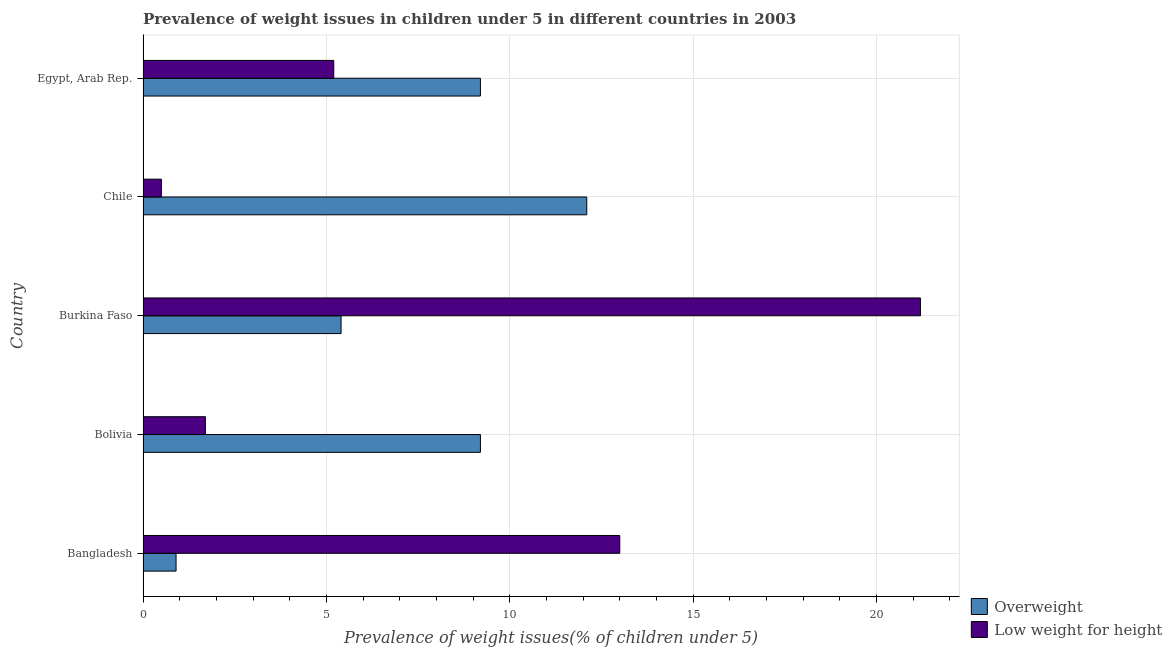How many different coloured bars are there?
Your answer should be very brief. 2. How many groups of bars are there?
Keep it short and to the point. 5. Are the number of bars per tick equal to the number of legend labels?
Ensure brevity in your answer.  Yes. How many bars are there on the 4th tick from the top?
Offer a terse response. 2. How many bars are there on the 1st tick from the bottom?
Your answer should be very brief. 2. In how many cases, is the number of bars for a given country not equal to the number of legend labels?
Give a very brief answer. 0. What is the percentage of underweight children in Bolivia?
Offer a very short reply. 1.7. Across all countries, what is the maximum percentage of overweight children?
Provide a succinct answer. 12.1. What is the total percentage of underweight children in the graph?
Offer a very short reply. 41.6. What is the difference between the percentage of underweight children in Egypt, Arab Rep. and the percentage of overweight children in Bolivia?
Your answer should be very brief. -4. What is the average percentage of underweight children per country?
Offer a very short reply. 8.32. What is the difference between the percentage of underweight children and percentage of overweight children in Bangladesh?
Give a very brief answer. 12.1. In how many countries, is the percentage of underweight children greater than 2 %?
Offer a terse response. 3. What is the ratio of the percentage of overweight children in Bolivia to that in Chile?
Provide a succinct answer. 0.76. Is the difference between the percentage of overweight children in Burkina Faso and Egypt, Arab Rep. greater than the difference between the percentage of underweight children in Burkina Faso and Egypt, Arab Rep.?
Provide a short and direct response. No. What is the difference between the highest and the second highest percentage of underweight children?
Ensure brevity in your answer.  8.2. What is the difference between the highest and the lowest percentage of underweight children?
Your answer should be compact. 20.7. In how many countries, is the percentage of overweight children greater than the average percentage of overweight children taken over all countries?
Provide a short and direct response. 3. Is the sum of the percentage of underweight children in Bangladesh and Chile greater than the maximum percentage of overweight children across all countries?
Give a very brief answer. Yes. What does the 2nd bar from the top in Chile represents?
Offer a very short reply. Overweight. What does the 2nd bar from the bottom in Burkina Faso represents?
Your response must be concise. Low weight for height. How many bars are there?
Provide a short and direct response. 10. Are all the bars in the graph horizontal?
Make the answer very short. Yes. How many countries are there in the graph?
Your answer should be very brief. 5. Does the graph contain grids?
Offer a terse response. Yes. Where does the legend appear in the graph?
Ensure brevity in your answer.  Bottom right. What is the title of the graph?
Your answer should be very brief. Prevalence of weight issues in children under 5 in different countries in 2003. What is the label or title of the X-axis?
Your answer should be compact. Prevalence of weight issues(% of children under 5). What is the Prevalence of weight issues(% of children under 5) of Overweight in Bangladesh?
Your response must be concise. 0.9. What is the Prevalence of weight issues(% of children under 5) in Low weight for height in Bangladesh?
Offer a very short reply. 13. What is the Prevalence of weight issues(% of children under 5) in Overweight in Bolivia?
Provide a succinct answer. 9.2. What is the Prevalence of weight issues(% of children under 5) of Low weight for height in Bolivia?
Your answer should be very brief. 1.7. What is the Prevalence of weight issues(% of children under 5) of Overweight in Burkina Faso?
Ensure brevity in your answer.  5.4. What is the Prevalence of weight issues(% of children under 5) of Low weight for height in Burkina Faso?
Your answer should be very brief. 21.2. What is the Prevalence of weight issues(% of children under 5) in Overweight in Chile?
Your answer should be compact. 12.1. What is the Prevalence of weight issues(% of children under 5) of Low weight for height in Chile?
Your answer should be compact. 0.5. What is the Prevalence of weight issues(% of children under 5) in Overweight in Egypt, Arab Rep.?
Offer a very short reply. 9.2. What is the Prevalence of weight issues(% of children under 5) in Low weight for height in Egypt, Arab Rep.?
Your response must be concise. 5.2. Across all countries, what is the maximum Prevalence of weight issues(% of children under 5) of Overweight?
Provide a short and direct response. 12.1. Across all countries, what is the maximum Prevalence of weight issues(% of children under 5) in Low weight for height?
Keep it short and to the point. 21.2. Across all countries, what is the minimum Prevalence of weight issues(% of children under 5) of Overweight?
Give a very brief answer. 0.9. What is the total Prevalence of weight issues(% of children under 5) of Overweight in the graph?
Keep it short and to the point. 36.8. What is the total Prevalence of weight issues(% of children under 5) in Low weight for height in the graph?
Give a very brief answer. 41.6. What is the difference between the Prevalence of weight issues(% of children under 5) of Overweight in Bangladesh and that in Bolivia?
Ensure brevity in your answer.  -8.3. What is the difference between the Prevalence of weight issues(% of children under 5) in Low weight for height in Bangladesh and that in Chile?
Make the answer very short. 12.5. What is the difference between the Prevalence of weight issues(% of children under 5) in Low weight for height in Bolivia and that in Burkina Faso?
Your answer should be very brief. -19.5. What is the difference between the Prevalence of weight issues(% of children under 5) of Low weight for height in Bolivia and that in Egypt, Arab Rep.?
Your answer should be very brief. -3.5. What is the difference between the Prevalence of weight issues(% of children under 5) in Overweight in Burkina Faso and that in Chile?
Your response must be concise. -6.7. What is the difference between the Prevalence of weight issues(% of children under 5) in Low weight for height in Burkina Faso and that in Chile?
Ensure brevity in your answer.  20.7. What is the difference between the Prevalence of weight issues(% of children under 5) in Low weight for height in Burkina Faso and that in Egypt, Arab Rep.?
Offer a very short reply. 16. What is the difference between the Prevalence of weight issues(% of children under 5) of Low weight for height in Chile and that in Egypt, Arab Rep.?
Your response must be concise. -4.7. What is the difference between the Prevalence of weight issues(% of children under 5) in Overweight in Bangladesh and the Prevalence of weight issues(% of children under 5) in Low weight for height in Bolivia?
Your response must be concise. -0.8. What is the difference between the Prevalence of weight issues(% of children under 5) in Overweight in Bangladesh and the Prevalence of weight issues(% of children under 5) in Low weight for height in Burkina Faso?
Your answer should be very brief. -20.3. What is the difference between the Prevalence of weight issues(% of children under 5) of Overweight in Bangladesh and the Prevalence of weight issues(% of children under 5) of Low weight for height in Chile?
Provide a short and direct response. 0.4. What is the difference between the Prevalence of weight issues(% of children under 5) in Overweight in Bangladesh and the Prevalence of weight issues(% of children under 5) in Low weight for height in Egypt, Arab Rep.?
Keep it short and to the point. -4.3. What is the difference between the Prevalence of weight issues(% of children under 5) in Overweight in Bolivia and the Prevalence of weight issues(% of children under 5) in Low weight for height in Chile?
Your answer should be compact. 8.7. What is the difference between the Prevalence of weight issues(% of children under 5) in Overweight in Bolivia and the Prevalence of weight issues(% of children under 5) in Low weight for height in Egypt, Arab Rep.?
Offer a terse response. 4. What is the difference between the Prevalence of weight issues(% of children under 5) in Overweight in Burkina Faso and the Prevalence of weight issues(% of children under 5) in Low weight for height in Chile?
Provide a succinct answer. 4.9. What is the difference between the Prevalence of weight issues(% of children under 5) of Overweight in Burkina Faso and the Prevalence of weight issues(% of children under 5) of Low weight for height in Egypt, Arab Rep.?
Your answer should be very brief. 0.2. What is the difference between the Prevalence of weight issues(% of children under 5) in Overweight in Chile and the Prevalence of weight issues(% of children under 5) in Low weight for height in Egypt, Arab Rep.?
Give a very brief answer. 6.9. What is the average Prevalence of weight issues(% of children under 5) of Overweight per country?
Your answer should be very brief. 7.36. What is the average Prevalence of weight issues(% of children under 5) of Low weight for height per country?
Your answer should be compact. 8.32. What is the difference between the Prevalence of weight issues(% of children under 5) of Overweight and Prevalence of weight issues(% of children under 5) of Low weight for height in Bangladesh?
Keep it short and to the point. -12.1. What is the difference between the Prevalence of weight issues(% of children under 5) in Overweight and Prevalence of weight issues(% of children under 5) in Low weight for height in Bolivia?
Your answer should be compact. 7.5. What is the difference between the Prevalence of weight issues(% of children under 5) in Overweight and Prevalence of weight issues(% of children under 5) in Low weight for height in Burkina Faso?
Ensure brevity in your answer.  -15.8. What is the ratio of the Prevalence of weight issues(% of children under 5) of Overweight in Bangladesh to that in Bolivia?
Keep it short and to the point. 0.1. What is the ratio of the Prevalence of weight issues(% of children under 5) in Low weight for height in Bangladesh to that in Bolivia?
Offer a very short reply. 7.65. What is the ratio of the Prevalence of weight issues(% of children under 5) of Overweight in Bangladesh to that in Burkina Faso?
Provide a short and direct response. 0.17. What is the ratio of the Prevalence of weight issues(% of children under 5) in Low weight for height in Bangladesh to that in Burkina Faso?
Provide a succinct answer. 0.61. What is the ratio of the Prevalence of weight issues(% of children under 5) of Overweight in Bangladesh to that in Chile?
Provide a short and direct response. 0.07. What is the ratio of the Prevalence of weight issues(% of children under 5) of Overweight in Bangladesh to that in Egypt, Arab Rep.?
Give a very brief answer. 0.1. What is the ratio of the Prevalence of weight issues(% of children under 5) of Overweight in Bolivia to that in Burkina Faso?
Your response must be concise. 1.7. What is the ratio of the Prevalence of weight issues(% of children under 5) of Low weight for height in Bolivia to that in Burkina Faso?
Offer a very short reply. 0.08. What is the ratio of the Prevalence of weight issues(% of children under 5) of Overweight in Bolivia to that in Chile?
Offer a terse response. 0.76. What is the ratio of the Prevalence of weight issues(% of children under 5) of Low weight for height in Bolivia to that in Egypt, Arab Rep.?
Make the answer very short. 0.33. What is the ratio of the Prevalence of weight issues(% of children under 5) of Overweight in Burkina Faso to that in Chile?
Your answer should be compact. 0.45. What is the ratio of the Prevalence of weight issues(% of children under 5) in Low weight for height in Burkina Faso to that in Chile?
Provide a short and direct response. 42.4. What is the ratio of the Prevalence of weight issues(% of children under 5) in Overweight in Burkina Faso to that in Egypt, Arab Rep.?
Ensure brevity in your answer.  0.59. What is the ratio of the Prevalence of weight issues(% of children under 5) of Low weight for height in Burkina Faso to that in Egypt, Arab Rep.?
Provide a succinct answer. 4.08. What is the ratio of the Prevalence of weight issues(% of children under 5) of Overweight in Chile to that in Egypt, Arab Rep.?
Your response must be concise. 1.32. What is the ratio of the Prevalence of weight issues(% of children under 5) in Low weight for height in Chile to that in Egypt, Arab Rep.?
Offer a very short reply. 0.1. What is the difference between the highest and the second highest Prevalence of weight issues(% of children under 5) of Overweight?
Give a very brief answer. 2.9. What is the difference between the highest and the lowest Prevalence of weight issues(% of children under 5) in Overweight?
Provide a succinct answer. 11.2. What is the difference between the highest and the lowest Prevalence of weight issues(% of children under 5) in Low weight for height?
Ensure brevity in your answer.  20.7. 